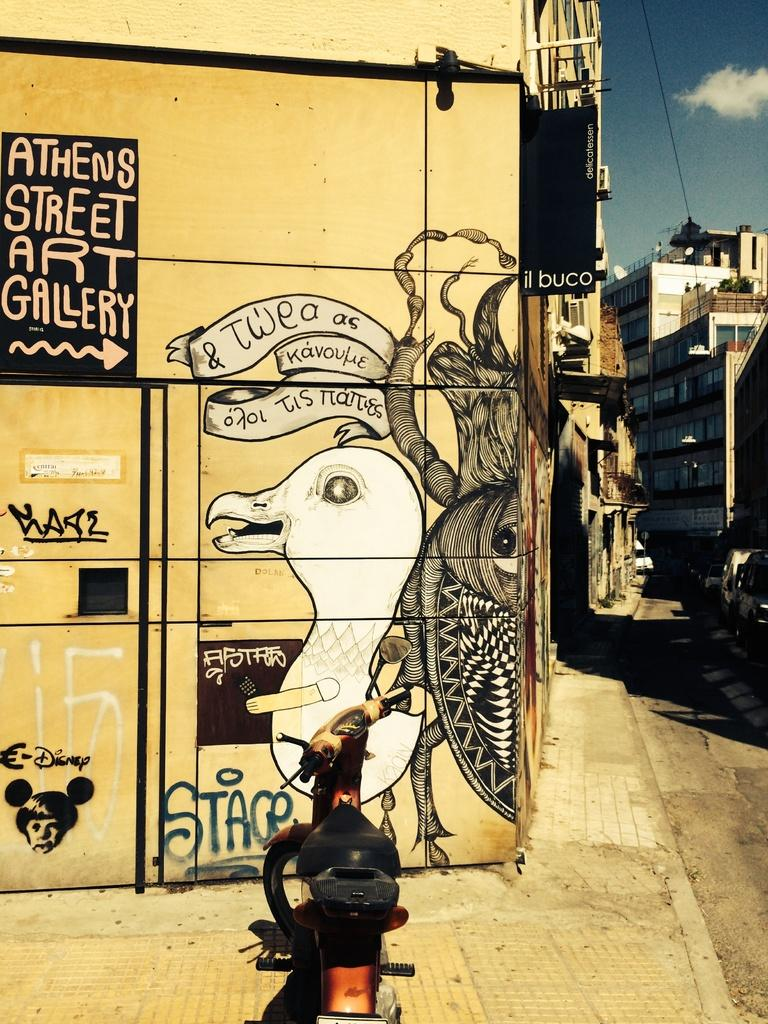<image>
Offer a succinct explanation of the picture presented. A cartoon graffiti drawing for Athens Street Art Gallery. 